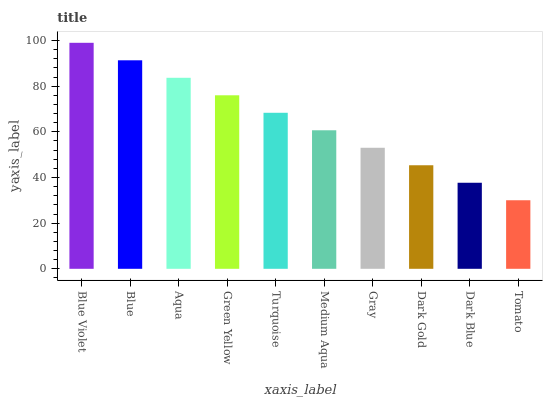Is Blue the minimum?
Answer yes or no. No. Is Blue the maximum?
Answer yes or no. No. Is Blue Violet greater than Blue?
Answer yes or no. Yes. Is Blue less than Blue Violet?
Answer yes or no. Yes. Is Blue greater than Blue Violet?
Answer yes or no. No. Is Blue Violet less than Blue?
Answer yes or no. No. Is Turquoise the high median?
Answer yes or no. Yes. Is Medium Aqua the low median?
Answer yes or no. Yes. Is Dark Blue the high median?
Answer yes or no. No. Is Green Yellow the low median?
Answer yes or no. No. 